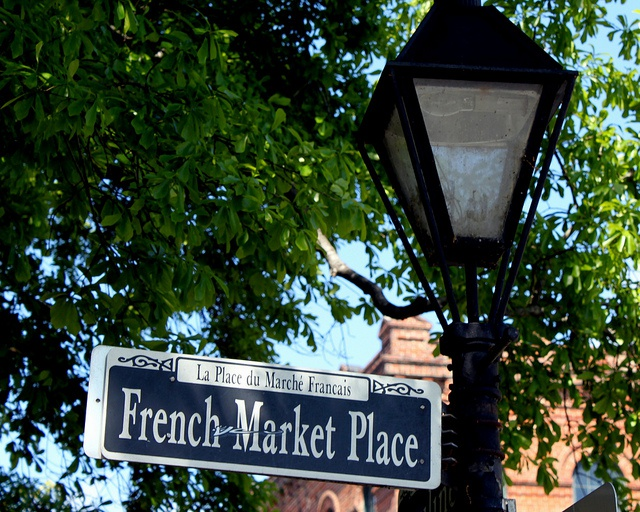Describe the objects in this image and their specific colors. I can see various objects in this image with different colors. 